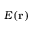Convert formula to latex. <formula><loc_0><loc_0><loc_500><loc_500>E ( r )</formula> 